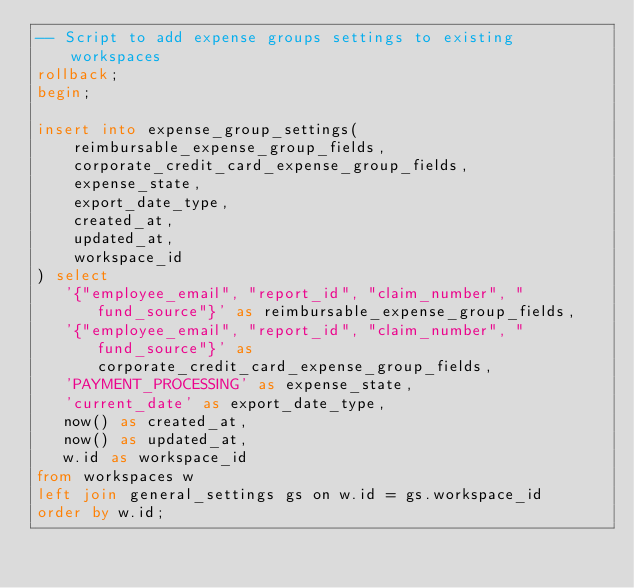Convert code to text. <code><loc_0><loc_0><loc_500><loc_500><_SQL_>-- Script to add expense groups settings to existing workspaces
rollback;
begin;

insert into expense_group_settings(
    reimbursable_expense_group_fields,
    corporate_credit_card_expense_group_fields,
    expense_state,
    export_date_type,
    created_at,
    updated_at,
    workspace_id
) select
   '{"employee_email", "report_id", "claim_number", "fund_source"}' as reimbursable_expense_group_fields,
   '{"employee_email", "report_id", "claim_number", "fund_source"}' as corporate_credit_card_expense_group_fields,
   'PAYMENT_PROCESSING' as expense_state,
   'current_date' as export_date_type,
   now() as created_at,
   now() as updated_at,
   w.id as workspace_id
from workspaces w
left join general_settings gs on w.id = gs.workspace_id
order by w.id;</code> 